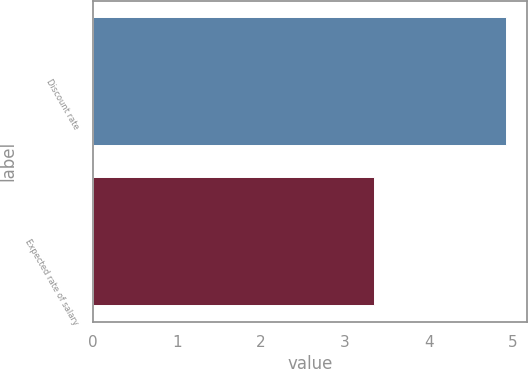Convert chart to OTSL. <chart><loc_0><loc_0><loc_500><loc_500><bar_chart><fcel>Discount rate<fcel>Expected rate of salary<nl><fcel>4.92<fcel>3.34<nl></chart> 